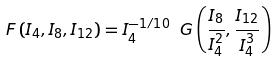Convert formula to latex. <formula><loc_0><loc_0><loc_500><loc_500>F \left ( I _ { 4 } , I _ { 8 } , I _ { 1 2 } \right ) = I _ { 4 } ^ { - 1 / 1 0 } \ G \left ( \frac { I _ { 8 } } { I _ { 4 } ^ { 2 } } , \frac { I _ { 1 2 } } { I _ { 4 } ^ { 3 } } \right )</formula> 